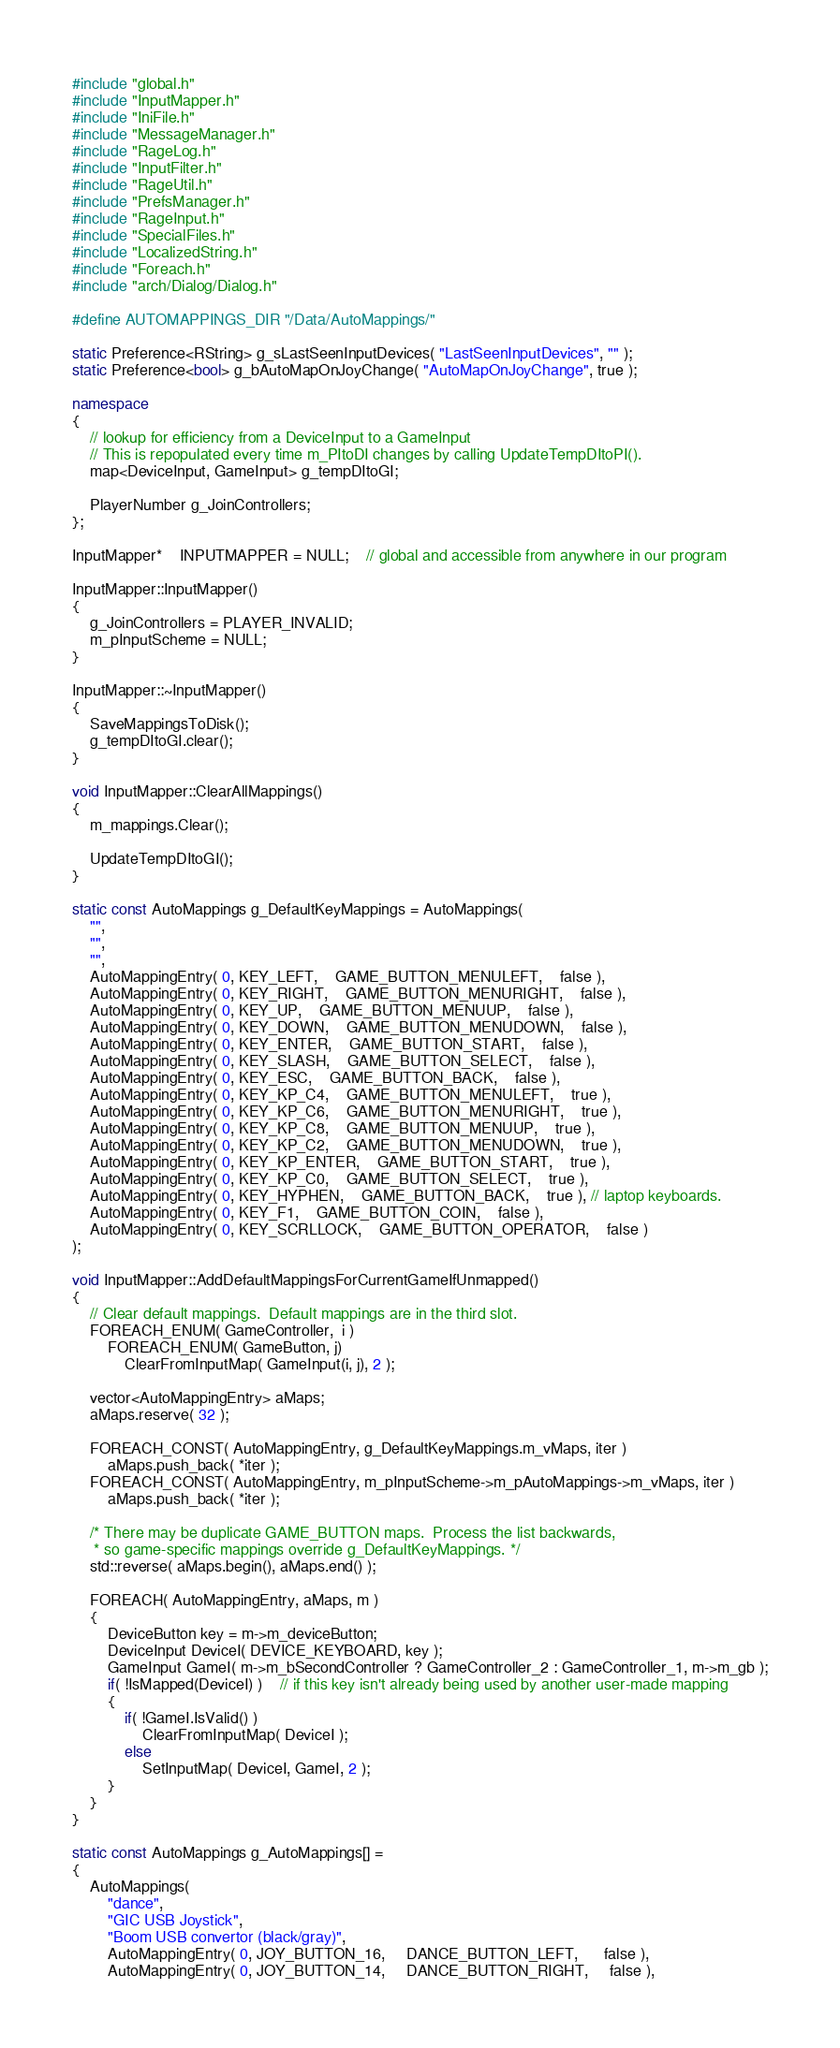Convert code to text. <code><loc_0><loc_0><loc_500><loc_500><_C++_>#include "global.h"
#include "InputMapper.h"
#include "IniFile.h"
#include "MessageManager.h"
#include "RageLog.h"
#include "InputFilter.h"
#include "RageUtil.h"
#include "PrefsManager.h"
#include "RageInput.h"
#include "SpecialFiles.h"
#include "LocalizedString.h"
#include "Foreach.h"
#include "arch/Dialog/Dialog.h"

#define AUTOMAPPINGS_DIR "/Data/AutoMappings/"

static Preference<RString> g_sLastSeenInputDevices( "LastSeenInputDevices", "" );
static Preference<bool> g_bAutoMapOnJoyChange( "AutoMapOnJoyChange", true );

namespace
{
	// lookup for efficiency from a DeviceInput to a GameInput
	// This is repopulated every time m_PItoDI changes by calling UpdateTempDItoPI().
	map<DeviceInput, GameInput> g_tempDItoGI;

	PlayerNumber g_JoinControllers;
};

InputMapper*	INPUTMAPPER = NULL;	// global and accessible from anywhere in our program

InputMapper::InputMapper()
{
	g_JoinControllers = PLAYER_INVALID;
	m_pInputScheme = NULL;
}

InputMapper::~InputMapper()
{
	SaveMappingsToDisk();
	g_tempDItoGI.clear();
}

void InputMapper::ClearAllMappings()
{
	m_mappings.Clear();

	UpdateTempDItoGI();
}

static const AutoMappings g_DefaultKeyMappings = AutoMappings(
	"",
	"",
	"",
	AutoMappingEntry( 0, KEY_LEFT,	GAME_BUTTON_MENULEFT,	false ),
	AutoMappingEntry( 0, KEY_RIGHT,	GAME_BUTTON_MENURIGHT,	false ),
	AutoMappingEntry( 0, KEY_UP,	GAME_BUTTON_MENUUP,	false ),
	AutoMappingEntry( 0, KEY_DOWN,	GAME_BUTTON_MENUDOWN,	false ),
	AutoMappingEntry( 0, KEY_ENTER,	GAME_BUTTON_START,	false ),
	AutoMappingEntry( 0, KEY_SLASH,	GAME_BUTTON_SELECT,	false ),
	AutoMappingEntry( 0, KEY_ESC,	GAME_BUTTON_BACK,	false ),
	AutoMappingEntry( 0, KEY_KP_C4,	GAME_BUTTON_MENULEFT,	true ),
	AutoMappingEntry( 0, KEY_KP_C6,	GAME_BUTTON_MENURIGHT,	true ),
	AutoMappingEntry( 0, KEY_KP_C8,	GAME_BUTTON_MENUUP,	true ),
	AutoMappingEntry( 0, KEY_KP_C2,	GAME_BUTTON_MENUDOWN,	true ),
	AutoMappingEntry( 0, KEY_KP_ENTER,	GAME_BUTTON_START,	true ),
	AutoMappingEntry( 0, KEY_KP_C0,	GAME_BUTTON_SELECT,	true ),
	AutoMappingEntry( 0, KEY_HYPHEN,	GAME_BUTTON_BACK,	true ), // laptop keyboards.
	AutoMappingEntry( 0, KEY_F1,	GAME_BUTTON_COIN,	false ),
	AutoMappingEntry( 0, KEY_SCRLLOCK,	GAME_BUTTON_OPERATOR,	false )
);

void InputMapper::AddDefaultMappingsForCurrentGameIfUnmapped()
{
	// Clear default mappings.  Default mappings are in the third slot.
	FOREACH_ENUM( GameController,  i )
		FOREACH_ENUM( GameButton, j)
			ClearFromInputMap( GameInput(i, j), 2 );

	vector<AutoMappingEntry> aMaps;
	aMaps.reserve( 32 );

	FOREACH_CONST( AutoMappingEntry, g_DefaultKeyMappings.m_vMaps, iter )
		aMaps.push_back( *iter );
	FOREACH_CONST( AutoMappingEntry, m_pInputScheme->m_pAutoMappings->m_vMaps, iter )
		aMaps.push_back( *iter );

	/* There may be duplicate GAME_BUTTON maps.  Process the list backwards,
	 * so game-specific mappings override g_DefaultKeyMappings. */
	std::reverse( aMaps.begin(), aMaps.end() );

	FOREACH( AutoMappingEntry, aMaps, m )
	{
		DeviceButton key = m->m_deviceButton;
		DeviceInput DeviceI( DEVICE_KEYBOARD, key );
		GameInput GameI( m->m_bSecondController ? GameController_2 : GameController_1, m->m_gb );
		if( !IsMapped(DeviceI) )	// if this key isn't already being used by another user-made mapping
		{
			if( !GameI.IsValid() )
				ClearFromInputMap( DeviceI );
			else
				SetInputMap( DeviceI, GameI, 2 );
		}
	}
}

static const AutoMappings g_AutoMappings[] =
{
	AutoMappings(
		"dance",
		"GIC USB Joystick",
		"Boom USB convertor (black/gray)",
		AutoMappingEntry( 0, JOY_BUTTON_16,     DANCE_BUTTON_LEFT,      false ),
		AutoMappingEntry( 0, JOY_BUTTON_14,     DANCE_BUTTON_RIGHT,     false ),</code> 